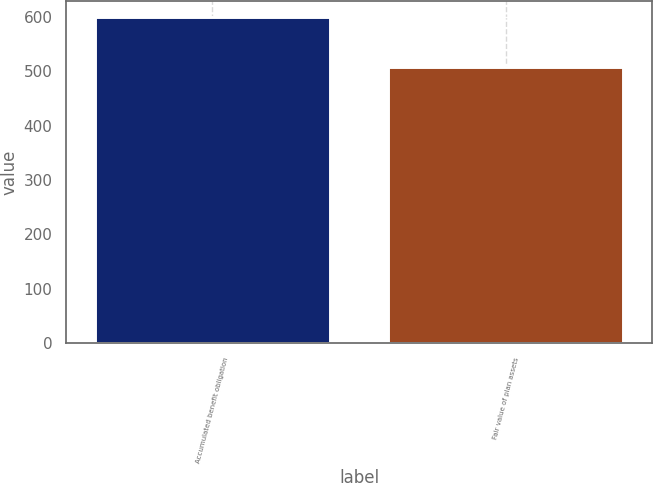Convert chart to OTSL. <chart><loc_0><loc_0><loc_500><loc_500><bar_chart><fcel>Accumulated benefit obligation<fcel>Fair value of plan assets<nl><fcel>599<fcel>508<nl></chart> 